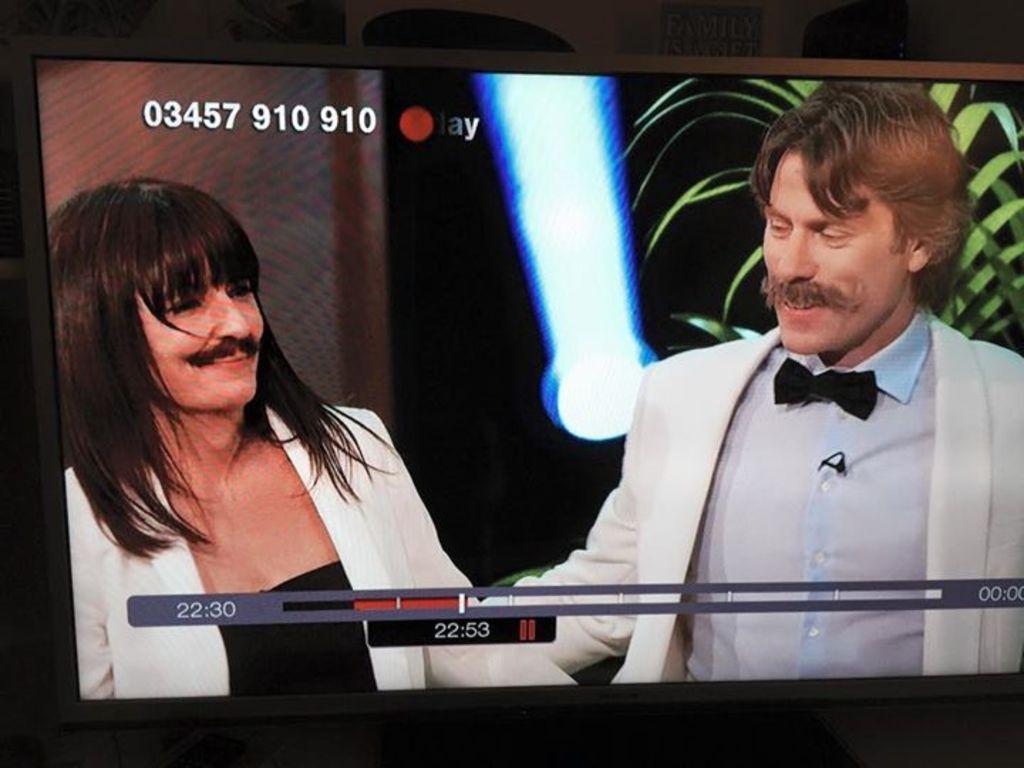Describe this image in one or two sentences. In the image I can see two people who are wearing suits and they have mustache and behind there is a light and a plant. 